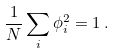Convert formula to latex. <formula><loc_0><loc_0><loc_500><loc_500>\frac { 1 } { N } \sum _ { i } \phi _ { i } ^ { 2 } = 1 \, .</formula> 